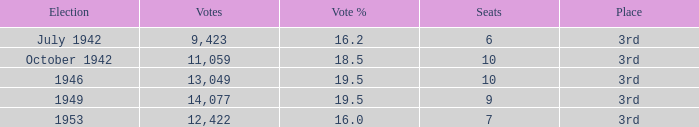Name the total number of seats for votes % more than 19.5 0.0. 